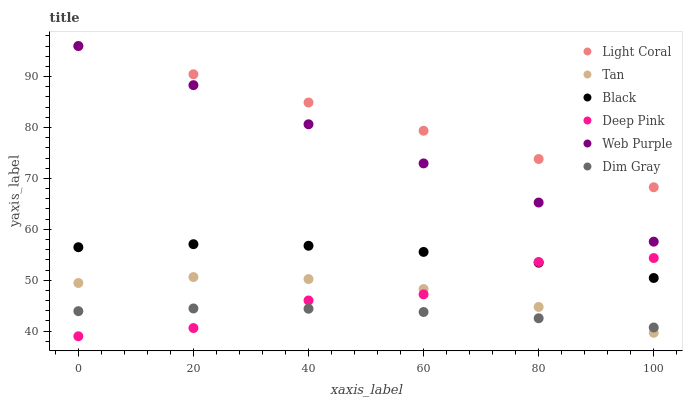Does Dim Gray have the minimum area under the curve?
Answer yes or no. Yes. Does Light Coral have the maximum area under the curve?
Answer yes or no. Yes. Does Web Purple have the minimum area under the curve?
Answer yes or no. No. Does Web Purple have the maximum area under the curve?
Answer yes or no. No. Is Web Purple the smoothest?
Answer yes or no. Yes. Is Deep Pink the roughest?
Answer yes or no. Yes. Is Light Coral the smoothest?
Answer yes or no. No. Is Light Coral the roughest?
Answer yes or no. No. Does Deep Pink have the lowest value?
Answer yes or no. Yes. Does Web Purple have the lowest value?
Answer yes or no. No. Does Web Purple have the highest value?
Answer yes or no. Yes. Does Dim Gray have the highest value?
Answer yes or no. No. Is Deep Pink less than Light Coral?
Answer yes or no. Yes. Is Web Purple greater than Deep Pink?
Answer yes or no. Yes. Does Web Purple intersect Light Coral?
Answer yes or no. Yes. Is Web Purple less than Light Coral?
Answer yes or no. No. Is Web Purple greater than Light Coral?
Answer yes or no. No. Does Deep Pink intersect Light Coral?
Answer yes or no. No. 